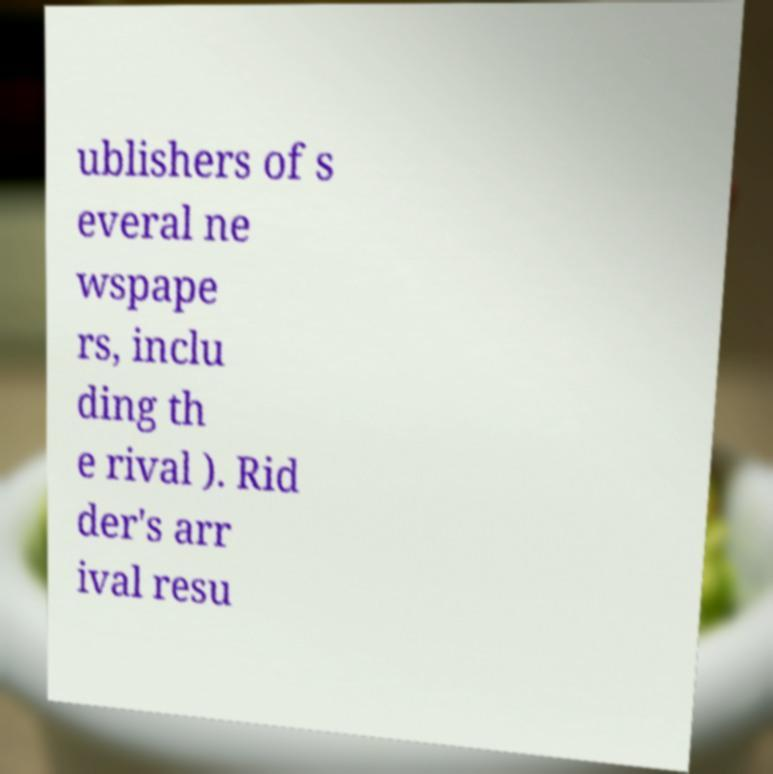Could you extract and type out the text from this image? ublishers of s everal ne wspape rs, inclu ding th e rival ). Rid der's arr ival resu 